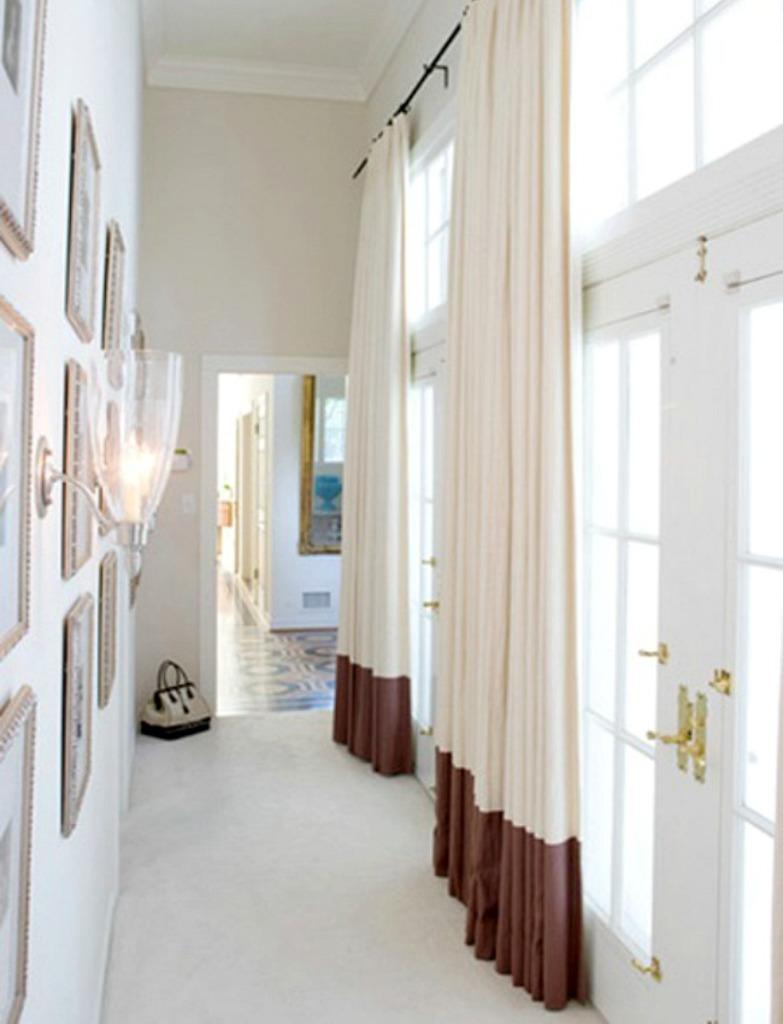Please provide a concise description of this image. In the image we can see there are curtains on the door, the wall is in white colour and there are photo frames on the wall. There is a light lamp on the wall and there is a hand purse kept on the floor. 